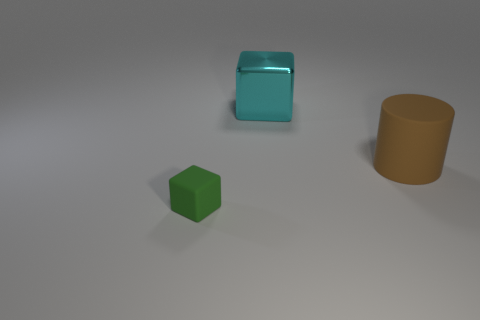Can you describe the colors and shapes visible in the image? Certainly! In the image, you can observe three distinct objects; a green cube, a cyan cube that appears to have a shiny surface, and behind it, to the right, a brown cylinder. The colors are solid and no object has any patterns or additional colors. 